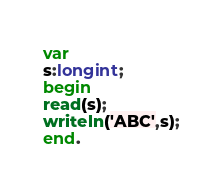<code> <loc_0><loc_0><loc_500><loc_500><_Pascal_>var
s:longint;
begin
read(s);
writeln('ABC',s);
end.</code> 